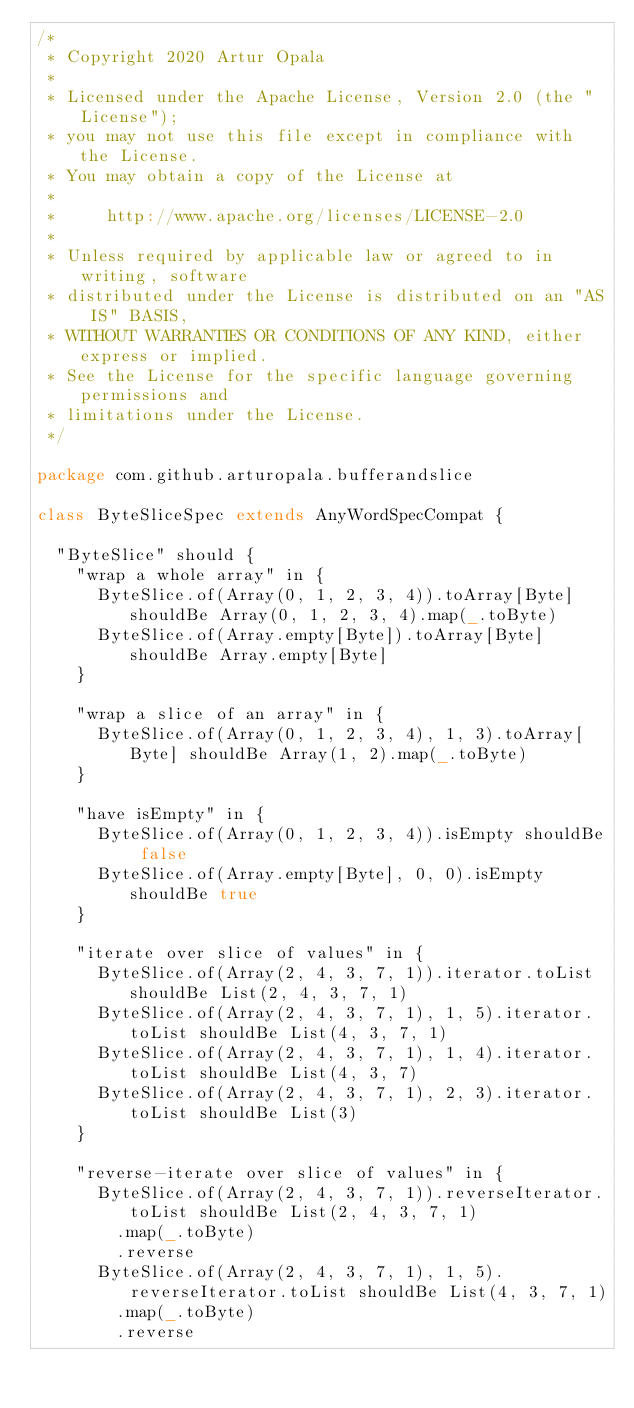<code> <loc_0><loc_0><loc_500><loc_500><_Scala_>/*
 * Copyright 2020 Artur Opala
 *
 * Licensed under the Apache License, Version 2.0 (the "License");
 * you may not use this file except in compliance with the License.
 * You may obtain a copy of the License at
 *
 *     http://www.apache.org/licenses/LICENSE-2.0
 *
 * Unless required by applicable law or agreed to in writing, software
 * distributed under the License is distributed on an "AS IS" BASIS,
 * WITHOUT WARRANTIES OR CONDITIONS OF ANY KIND, either express or implied.
 * See the License for the specific language governing permissions and
 * limitations under the License.
 */

package com.github.arturopala.bufferandslice

class ByteSliceSpec extends AnyWordSpecCompat {

  "ByteSlice" should {
    "wrap a whole array" in {
      ByteSlice.of(Array(0, 1, 2, 3, 4)).toArray[Byte] shouldBe Array(0, 1, 2, 3, 4).map(_.toByte)
      ByteSlice.of(Array.empty[Byte]).toArray[Byte] shouldBe Array.empty[Byte]
    }

    "wrap a slice of an array" in {
      ByteSlice.of(Array(0, 1, 2, 3, 4), 1, 3).toArray[Byte] shouldBe Array(1, 2).map(_.toByte)
    }

    "have isEmpty" in {
      ByteSlice.of(Array(0, 1, 2, 3, 4)).isEmpty shouldBe false
      ByteSlice.of(Array.empty[Byte], 0, 0).isEmpty shouldBe true
    }

    "iterate over slice of values" in {
      ByteSlice.of(Array(2, 4, 3, 7, 1)).iterator.toList shouldBe List(2, 4, 3, 7, 1)
      ByteSlice.of(Array(2, 4, 3, 7, 1), 1, 5).iterator.toList shouldBe List(4, 3, 7, 1)
      ByteSlice.of(Array(2, 4, 3, 7, 1), 1, 4).iterator.toList shouldBe List(4, 3, 7)
      ByteSlice.of(Array(2, 4, 3, 7, 1), 2, 3).iterator.toList shouldBe List(3)
    }

    "reverse-iterate over slice of values" in {
      ByteSlice.of(Array(2, 4, 3, 7, 1)).reverseIterator.toList shouldBe List(2, 4, 3, 7, 1)
        .map(_.toByte)
        .reverse
      ByteSlice.of(Array(2, 4, 3, 7, 1), 1, 5).reverseIterator.toList shouldBe List(4, 3, 7, 1)
        .map(_.toByte)
        .reverse</code> 